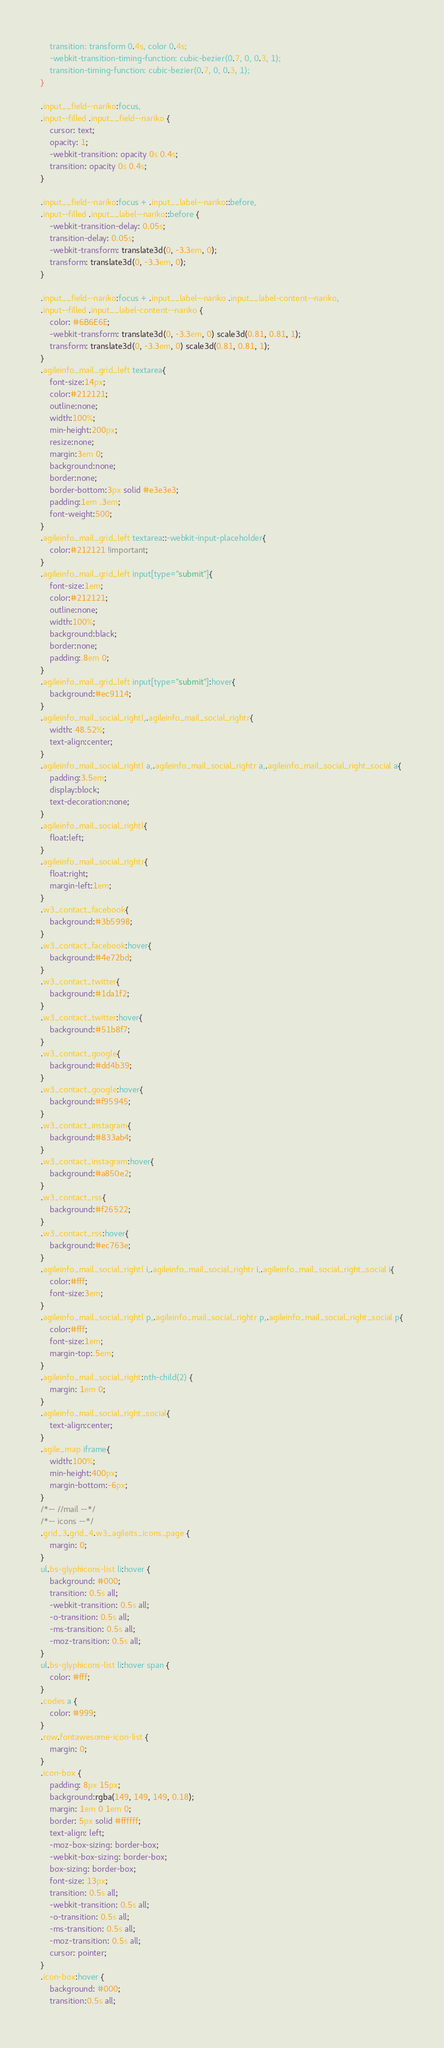<code> <loc_0><loc_0><loc_500><loc_500><_CSS_>	transition: transform 0.4s, color 0.4s;
	-webkit-transition-timing-function: cubic-bezier(0.7, 0, 0.3, 1);
	transition-timing-function: cubic-bezier(0.7, 0, 0.3, 1);
}

.input__field--nariko:focus,
.input--filled .input__field--nariko {
	cursor: text;
	opacity: 1;
	-webkit-transition: opacity 0s 0.4s;
	transition: opacity 0s 0.4s;
} 

.input__field--nariko:focus + .input__label--nariko::before,
.input--filled .input__label--nariko::before {
	-webkit-transition-delay: 0.05s;
	transition-delay: 0.05s;
	-webkit-transform: translate3d(0, -3.3em, 0);
	transform: translate3d(0, -3.3em, 0);
}

.input__field--nariko:focus + .input__label--nariko .input__label-content--nariko,
.input--filled .input__label-content--nariko {
	color: #6B6E6E;
	-webkit-transform: translate3d(0, -3.3em, 0) scale3d(0.81, 0.81, 1);
	transform: translate3d(0, -3.3em, 0) scale3d(0.81, 0.81, 1);
}
.agileinfo_mail_grid_left textarea{
	font-size:14px;
	color:#212121;
	outline:none;
	width:100%;
	min-height:200px;
	resize:none;
	margin:3em 0;
	background:none;
	border:none;
	border-bottom:3px solid #e3e3e3;
	padding:1em .3em;
	font-weight:500;
}
.agileinfo_mail_grid_left textarea::-webkit-input-placeholder{
	color:#212121 !important;
}
.agileinfo_mail_grid_left input[type="submit"]{
	font-size:1em;
	color:#212121;
	outline:none;
	width:100%;
	background:black;
	border:none;
	padding:.8em 0;
}
.agileinfo_mail_grid_left input[type="submit"]:hover{
	background:#ec9114;
}
.agileinfo_mail_social_rightl,.agileinfo_mail_social_rightr{
	width: 48.52%;
	text-align:center;
}
.agileinfo_mail_social_rightl a,.agileinfo_mail_social_rightr a,.agileinfo_mail_social_right_social a{
	padding:3.5em;
	display:block;
	text-decoration:none;
}
.agileinfo_mail_social_rightl{
	float:left;
}
.agileinfo_mail_social_rightr{
	float:right;
	margin-left:1em;
}
.w3_contact_facebook{
	background:#3b5998;
}
.w3_contact_facebook:hover{
	background:#4e72bd;
}
.w3_contact_twitter{
	background:#1da1f2;
}
.w3_contact_twitter:hover{
	background:#51b8f7;
}
.w3_contact_google{
	background:#dd4b39;
}
.w3_contact_google:hover{
	background:#f95945;
}
.w3_contact_instagram{
	background:#833ab4;
}
.w3_contact_instagram:hover{
	background:#a850e2;
}
.w3_contact_rss{
	background:#f26522;
}
.w3_contact_rss:hover{
	background:#ec763e;
}
.agileinfo_mail_social_rightl i,.agileinfo_mail_social_rightr i,.agileinfo_mail_social_right_social i{
	color:#fff;
	font-size:3em;
}
.agileinfo_mail_social_rightl p,.agileinfo_mail_social_rightr p,.agileinfo_mail_social_right_social p{
	color:#fff;
	font-size:1em;
	margin-top:.5em;
}
.agileinfo_mail_social_right:nth-child(2) {
    margin: 1em 0;
}
.agileinfo_mail_social_right_social{
	text-align:center;
}
.agile_map iframe{
	width:100%;
	min-height:400px;
	margin-bottom:-6px;
}
/*-- //mail --*/
/*-- icons --*/
.grid_3.grid_4.w3_agileits_icons_page {
    margin: 0;
}
ul.bs-glyphicons-list li:hover {
    background: #000;
    transition: 0.5s all;
    -webkit-transition: 0.5s all;
    -o-transition: 0.5s all;
    -ms-transition: 0.5s all;
    -moz-transition: 0.5s all;
}
ul.bs-glyphicons-list li:hover span {
    color: #fff;
}
.codes a {
    color: #999;
}
.row.fontawesome-icon-list {
    margin: 0;
}
.icon-box {
    padding: 8px 15px;
    background:rgba(149, 149, 149, 0.18);
    margin: 1em 0 1em 0;
    border: 5px solid #ffffff;
    text-align: left;
    -moz-box-sizing: border-box;
    -webkit-box-sizing: border-box;
    box-sizing: border-box;
    font-size: 13px;
    transition: 0.5s all;
    -webkit-transition: 0.5s all;
    -o-transition: 0.5s all;
    -ms-transition: 0.5s all;
    -moz-transition: 0.5s all;
    cursor: pointer;
} 
.icon-box:hover {
    background: #000;
	transition:0.5s all;</code> 